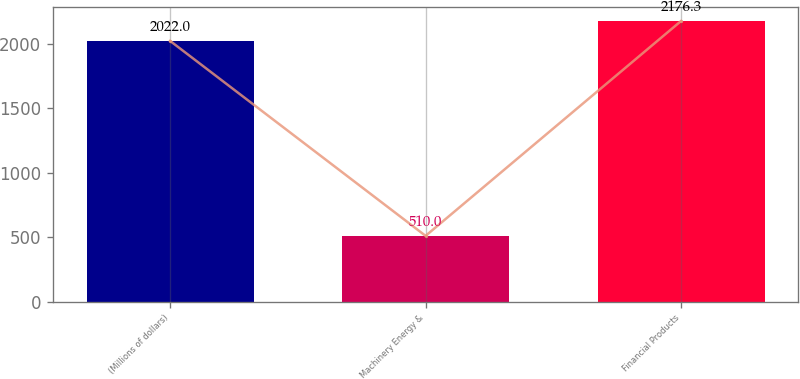<chart> <loc_0><loc_0><loc_500><loc_500><bar_chart><fcel>(Millions of dollars)<fcel>Machinery Energy &<fcel>Financial Products<nl><fcel>2022<fcel>510<fcel>2176.3<nl></chart> 